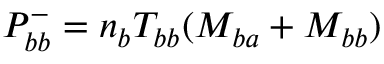<formula> <loc_0><loc_0><loc_500><loc_500>P _ { b b } ^ { - } = n _ { b } T _ { b b } ( M _ { b a } + M _ { b b } )</formula> 